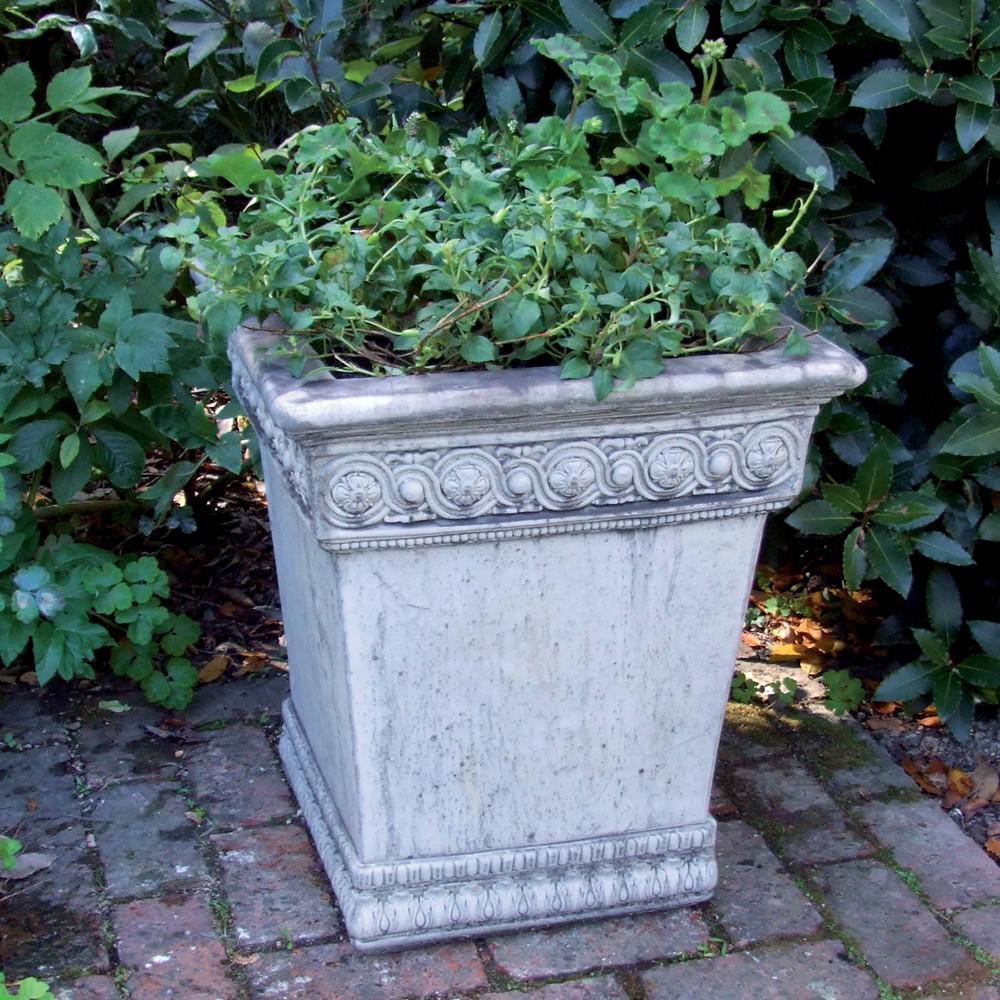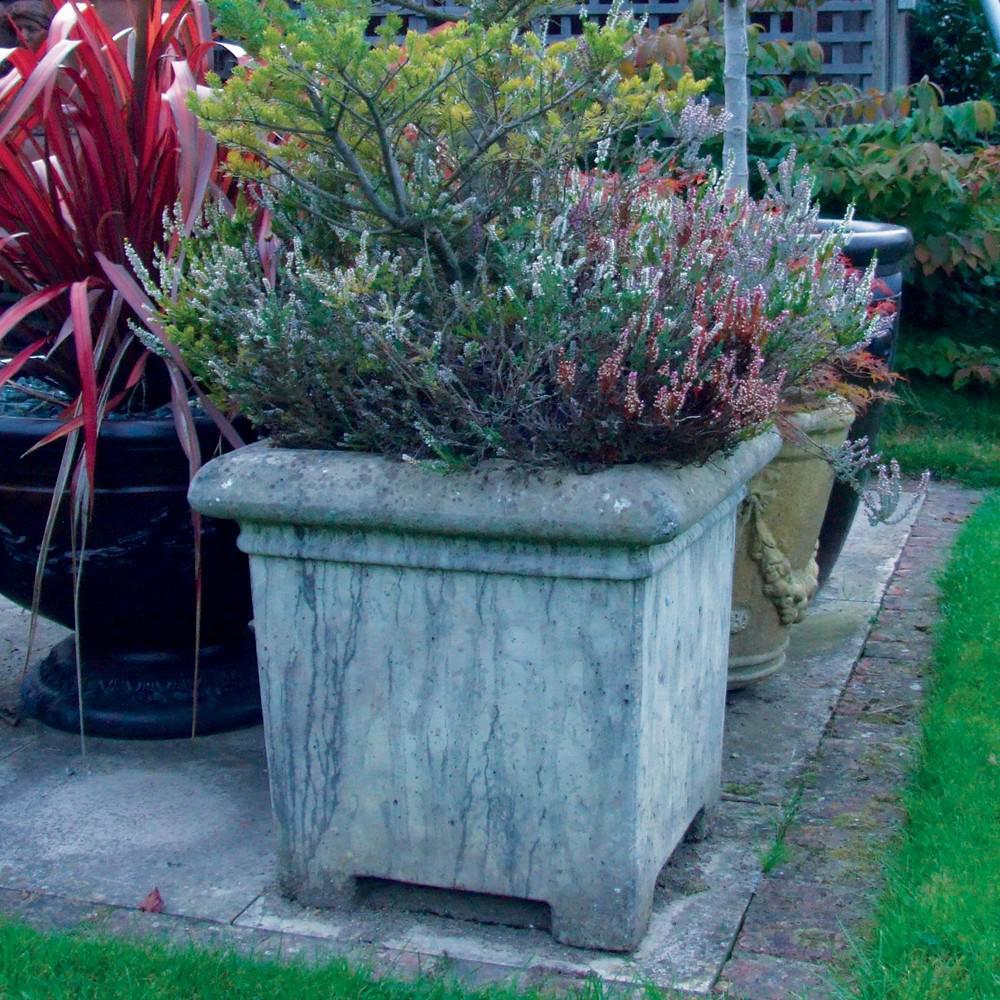The first image is the image on the left, the second image is the image on the right. For the images displayed, is the sentence "An image shows a bowl-shaped stone-look planter on a column pedestal, with a plant in the bowl." factually correct? Answer yes or no. No. 